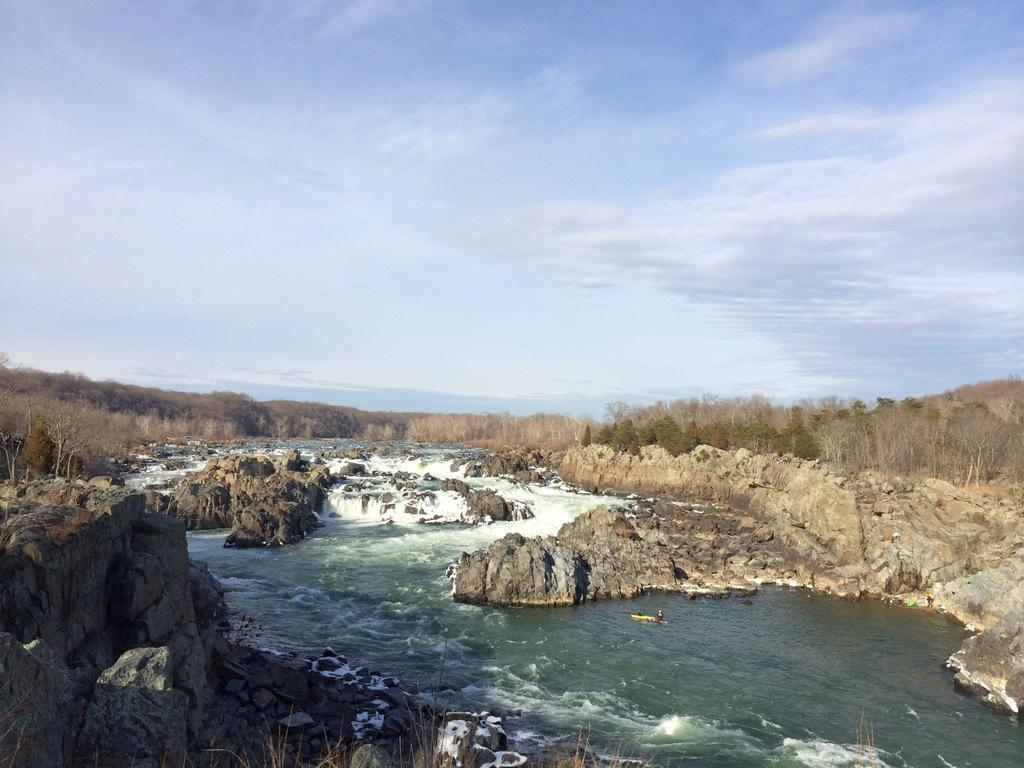What is the main feature in the center of the image? There is water in the center of the image. What can be seen on the right side of the image? There are rocks on the right side of the image. What is present on the left side of the image? There are rocks on the left side of the image. What type of vegetation is in the center of the image? There are trees in the center of the image. Where is the throne located in the image? There is no throne present in the image. What type of wood can be seen in the image? There is no specific type of wood mentioned or visible in the image. 